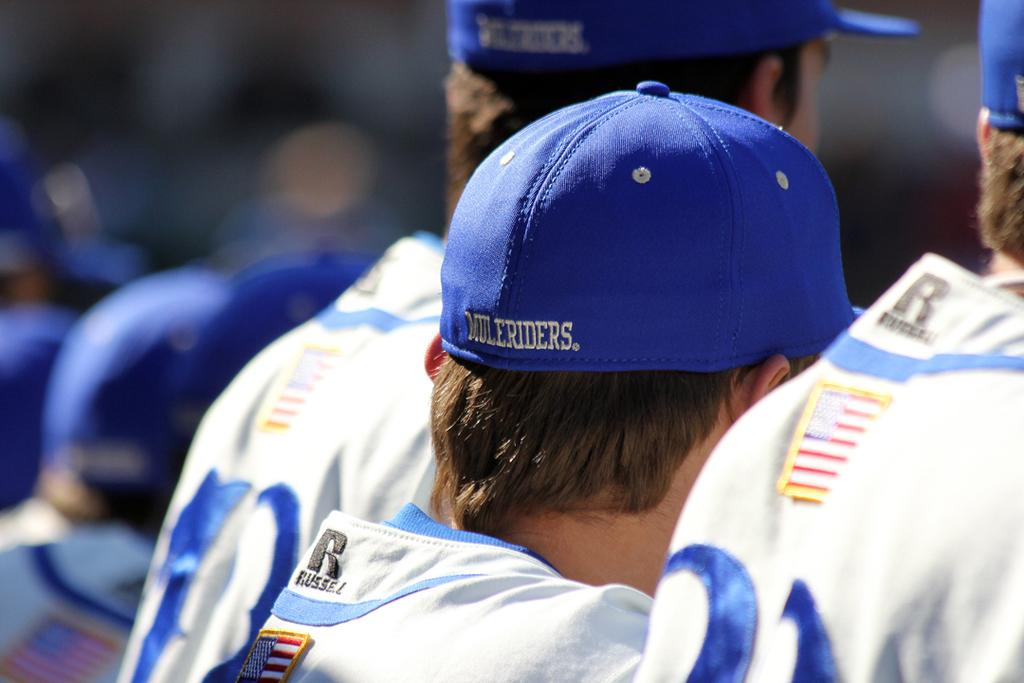<image>
Render a clear and concise summary of the photo. The back of some sports players heads are shown wearing a blue cap with MULERIDERS on the back of it. 